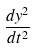Convert formula to latex. <formula><loc_0><loc_0><loc_500><loc_500>\frac { d y ^ { 2 } } { d t ^ { 2 } }</formula> 